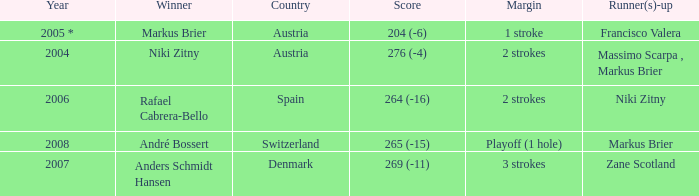What was the score in the year 2004? 276 (-4). 